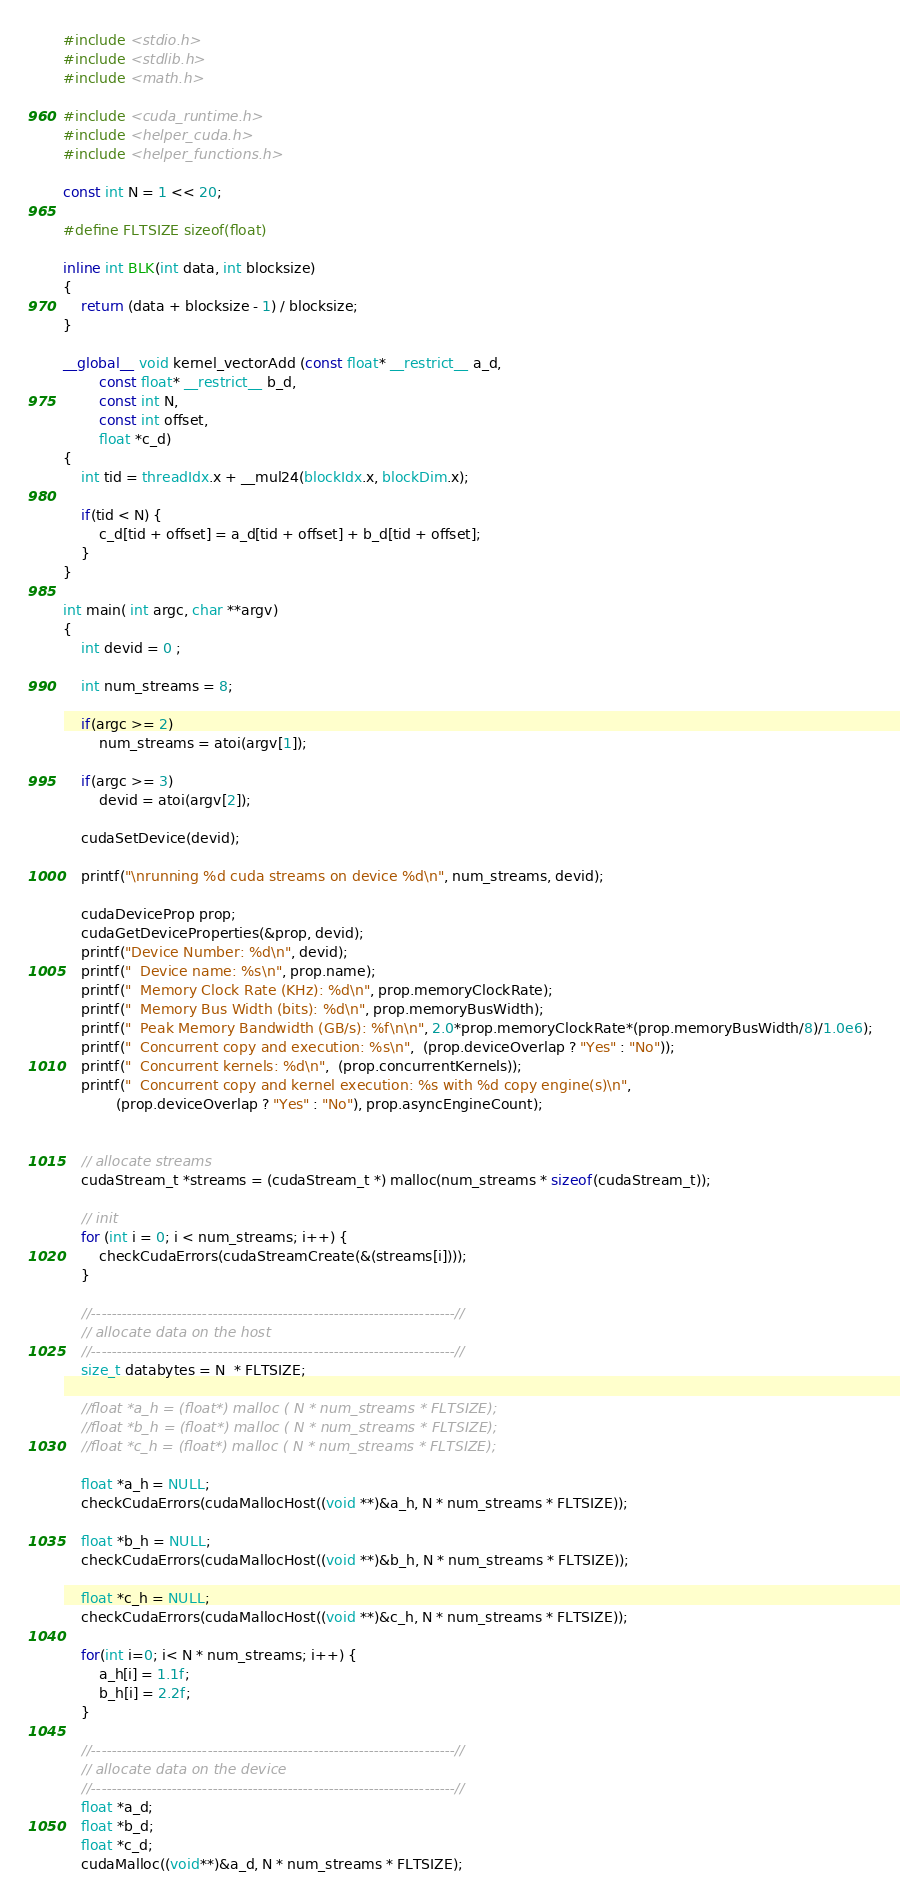Convert code to text. <code><loc_0><loc_0><loc_500><loc_500><_Cuda_>#include <stdio.h>
#include <stdlib.h>
#include <math.h>

#include <cuda_runtime.h>
#include <helper_cuda.h>
#include <helper_functions.h>

const int N = 1 << 20;

#define FLTSIZE sizeof(float)

inline int BLK(int data, int blocksize)
{
	return (data + blocksize - 1) / blocksize;
}

__global__ void kernel_vectorAdd (const float* __restrict__ a_d, 
		const float* __restrict__ b_d,
		const int N,
		const int offset,
		float *c_d)
{
	int tid = threadIdx.x + __mul24(blockIdx.x, blockDim.x);

	if(tid < N) {
		c_d[tid + offset] = a_d[tid + offset] + b_d[tid + offset];	
	}
}

int main( int argc, char **argv)
{
	int devid = 0 ;

	int num_streams = 8;

	if(argc >= 2)
		num_streams = atoi(argv[1]);

	if(argc >= 3)
		devid = atoi(argv[2]);

	cudaSetDevice(devid);

	printf("\nrunning %d cuda streams on device %d\n", num_streams, devid);

	cudaDeviceProp prop;
	cudaGetDeviceProperties(&prop, devid);
	printf("Device Number: %d\n", devid);
	printf("  Device name: %s\n", prop.name);
	printf("  Memory Clock Rate (KHz): %d\n", prop.memoryClockRate);
	printf("  Memory Bus Width (bits): %d\n", prop.memoryBusWidth);
	printf("  Peak Memory Bandwidth (GB/s): %f\n\n", 2.0*prop.memoryClockRate*(prop.memoryBusWidth/8)/1.0e6);
	printf("  Concurrent copy and execution: %s\n",  (prop.deviceOverlap ? "Yes" : "No"));
	printf("  Concurrent kernels: %d\n",  (prop.concurrentKernels));
	printf("  Concurrent copy and kernel execution: %s with %d copy engine(s)\n", 
			(prop.deviceOverlap ? "Yes" : "No"), prop.asyncEngineCount);


	// allocate streams
    cudaStream_t *streams = (cudaStream_t *) malloc(num_streams * sizeof(cudaStream_t));

	// init
    for (int i = 0; i < num_streams; i++) {
        checkCudaErrors(cudaStreamCreate(&(streams[i])));
    }

	//------------------------------------------------------------------------//
	// allocate data on the host
	//------------------------------------------------------------------------//
	size_t databytes = N  * FLTSIZE; 

	//float *a_h = (float*) malloc ( N * num_streams * FLTSIZE);
	//float *b_h = (float*) malloc ( N * num_streams * FLTSIZE);
	//float *c_h = (float*) malloc ( N * num_streams * FLTSIZE);

	float *a_h = NULL;
    checkCudaErrors(cudaMallocHost((void **)&a_h, N * num_streams * FLTSIZE));

	float *b_h = NULL;
    checkCudaErrors(cudaMallocHost((void **)&b_h, N * num_streams * FLTSIZE));

	float *c_h = NULL;
    checkCudaErrors(cudaMallocHost((void **)&c_h, N * num_streams * FLTSIZE));

	for(int i=0; i< N * num_streams; i++) {
		a_h[i] = 1.1f;	
		b_h[i] = 2.2f;	
	}

	//------------------------------------------------------------------------//
	// allocate data on the device 
	//------------------------------------------------------------------------//
	float *a_d;
	float *b_d;
	float *c_d;
	cudaMalloc((void**)&a_d, N * num_streams * FLTSIZE);</code> 